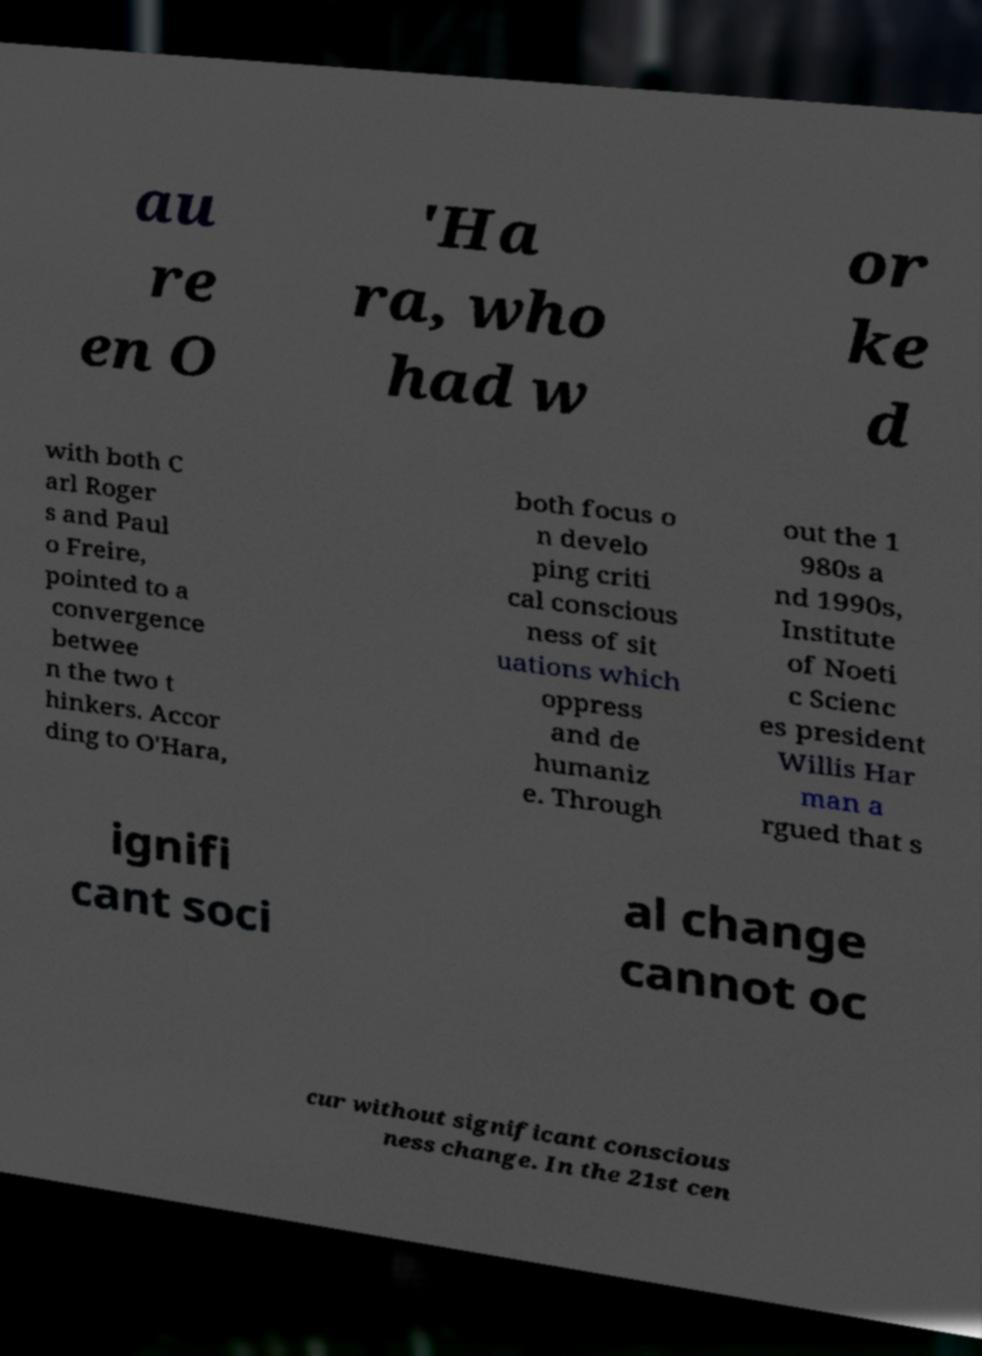Can you accurately transcribe the text from the provided image for me? au re en O 'Ha ra, who had w or ke d with both C arl Roger s and Paul o Freire, pointed to a convergence betwee n the two t hinkers. Accor ding to O'Hara, both focus o n develo ping criti cal conscious ness of sit uations which oppress and de humaniz e. Through out the 1 980s a nd 1990s, Institute of Noeti c Scienc es president Willis Har man a rgued that s ignifi cant soci al change cannot oc cur without significant conscious ness change. In the 21st cen 